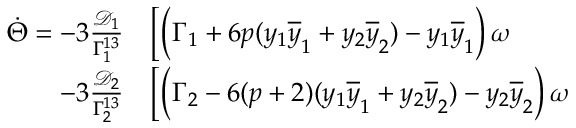Convert formula to latex. <formula><loc_0><loc_0><loc_500><loc_500>\begin{array} { r l } { \dot { \Theta } = - 3 \frac { \mathcal { D } _ { 1 } } { \Gamma _ { 1 } ^ { 1 3 } } } & \Big [ \Big ( \Gamma _ { 1 } + 6 p ( y _ { 1 } \overline { y } _ { 1 } + y _ { 2 } \overline { y } _ { 2 } ) - y _ { 1 } \overline { y } _ { 1 } \Big ) \, \omega } \\ { - 3 \frac { \mathcal { D } _ { 2 } } { \Gamma _ { 2 } ^ { 1 3 } } } & \Big [ \Big ( \Gamma _ { 2 } - 6 ( p + 2 ) ( y _ { 1 } \overline { y } _ { 1 } + y _ { 2 } \overline { y } _ { 2 } ) - y _ { 2 } \overline { y } _ { 2 } \Big ) \, \omega } \end{array}</formula> 